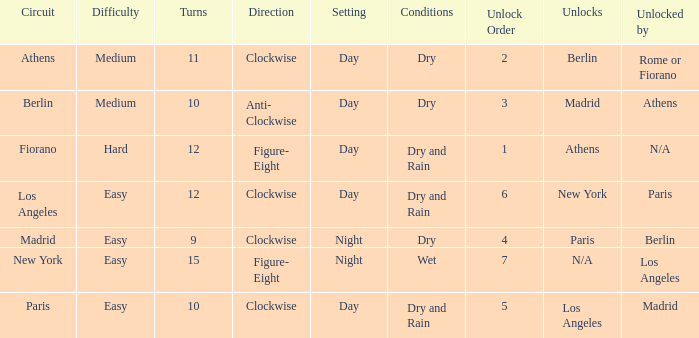What is the setting for the hard difficulty? Day. 